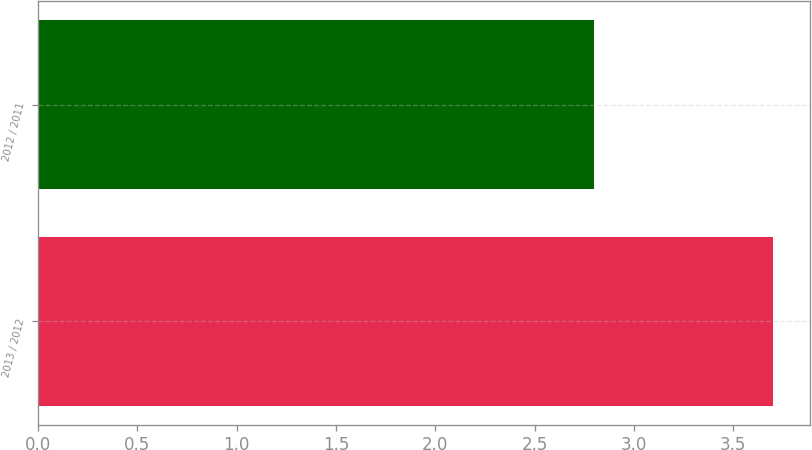Convert chart. <chart><loc_0><loc_0><loc_500><loc_500><bar_chart><fcel>2013 / 2012<fcel>2012 / 2011<nl><fcel>3.7<fcel>2.8<nl></chart> 